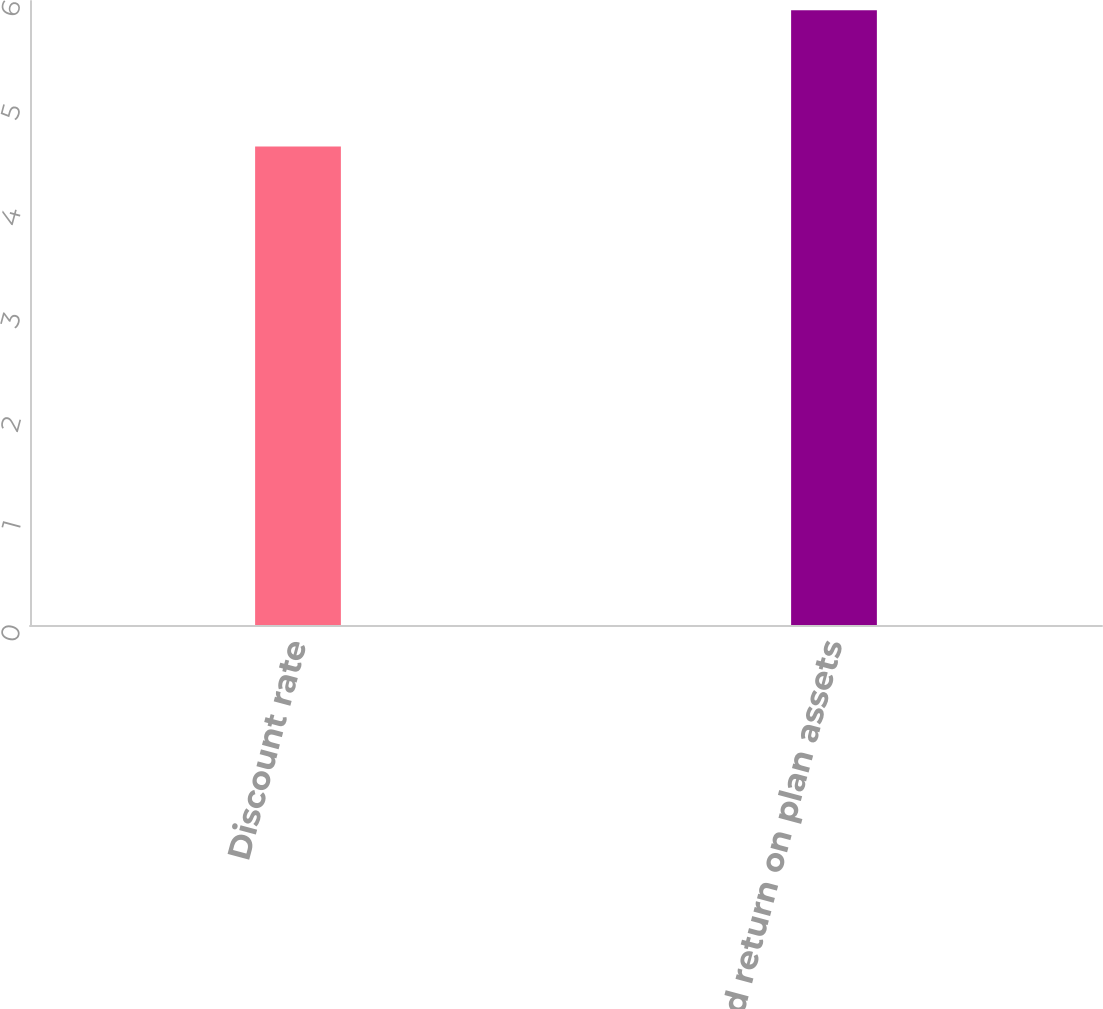Convert chart. <chart><loc_0><loc_0><loc_500><loc_500><bar_chart><fcel>Discount rate<fcel>Expected return on plan assets<nl><fcel>4.6<fcel>5.91<nl></chart> 